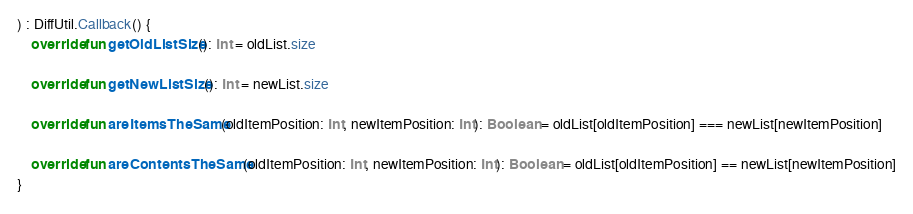Convert code to text. <code><loc_0><loc_0><loc_500><loc_500><_Kotlin_>) : DiffUtil.Callback() {
    override fun getOldListSize(): Int = oldList.size

    override fun getNewListSize(): Int = newList.size

    override fun areItemsTheSame(oldItemPosition: Int, newItemPosition: Int): Boolean = oldList[oldItemPosition] === newList[newItemPosition]

    override fun areContentsTheSame(oldItemPosition: Int, newItemPosition: Int): Boolean = oldList[oldItemPosition] == newList[newItemPosition]
}</code> 